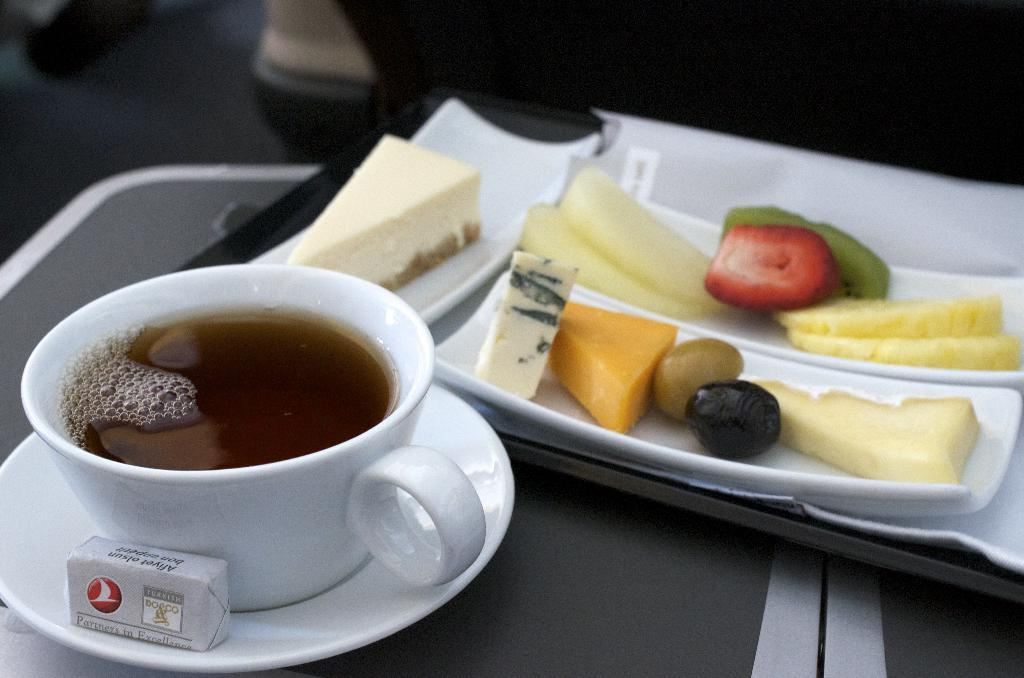What is on the table in the image? There is a coffee cup, a food packet, a saucer, plates, and food on the table. What might be used to hold the coffee cup? The saucer on the table can be used to hold the coffee cup. What type of food is visible on the table? The image shows food on the table, but the specific type of food is not clear. How is the background of the image depicted? The background of the image is blurred. How many frogs are sitting on the food packet in the image? There are no frogs present in the image; it only shows a coffee cup, a food packet, a saucer, plates, and food on the table. 